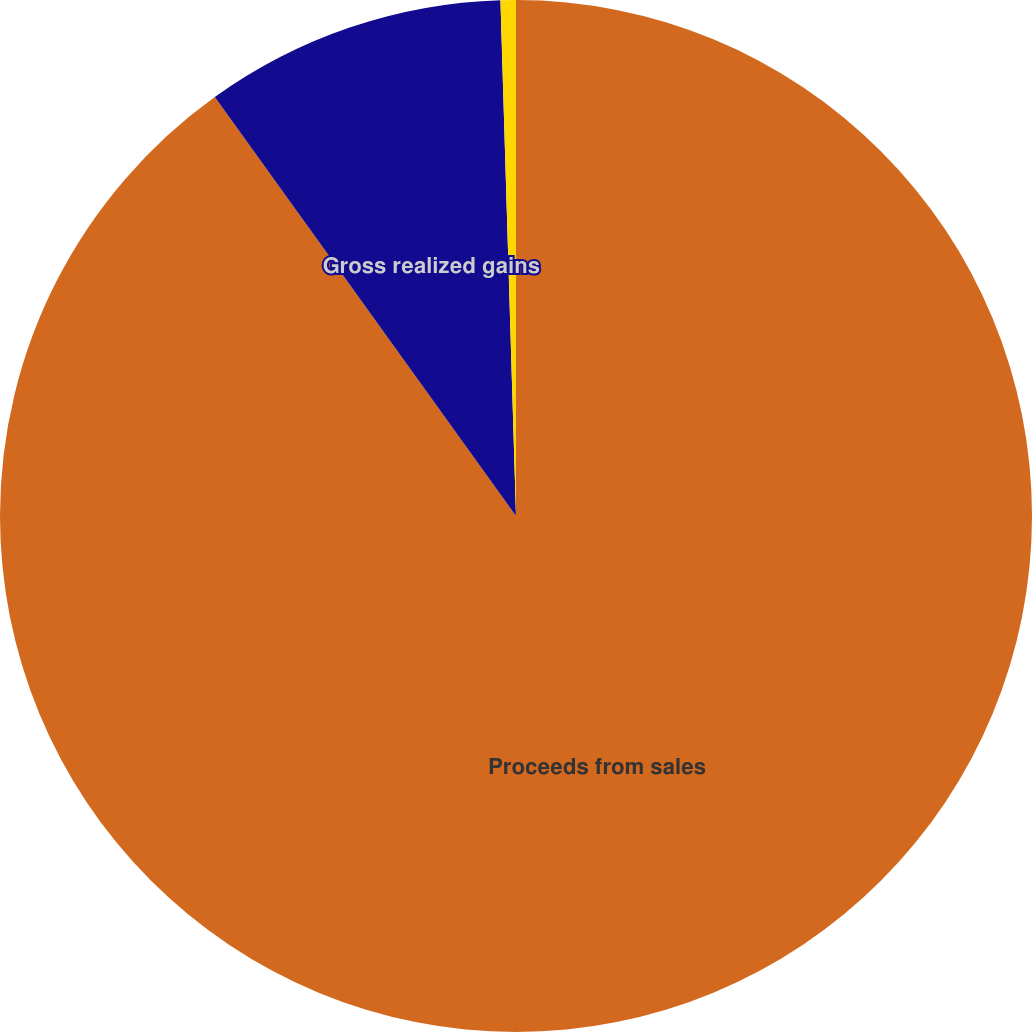Convert chart to OTSL. <chart><loc_0><loc_0><loc_500><loc_500><pie_chart><fcel>Proceeds from sales<fcel>Gross realized gains<fcel>Gross realized losses<nl><fcel>90.08%<fcel>9.44%<fcel>0.48%<nl></chart> 